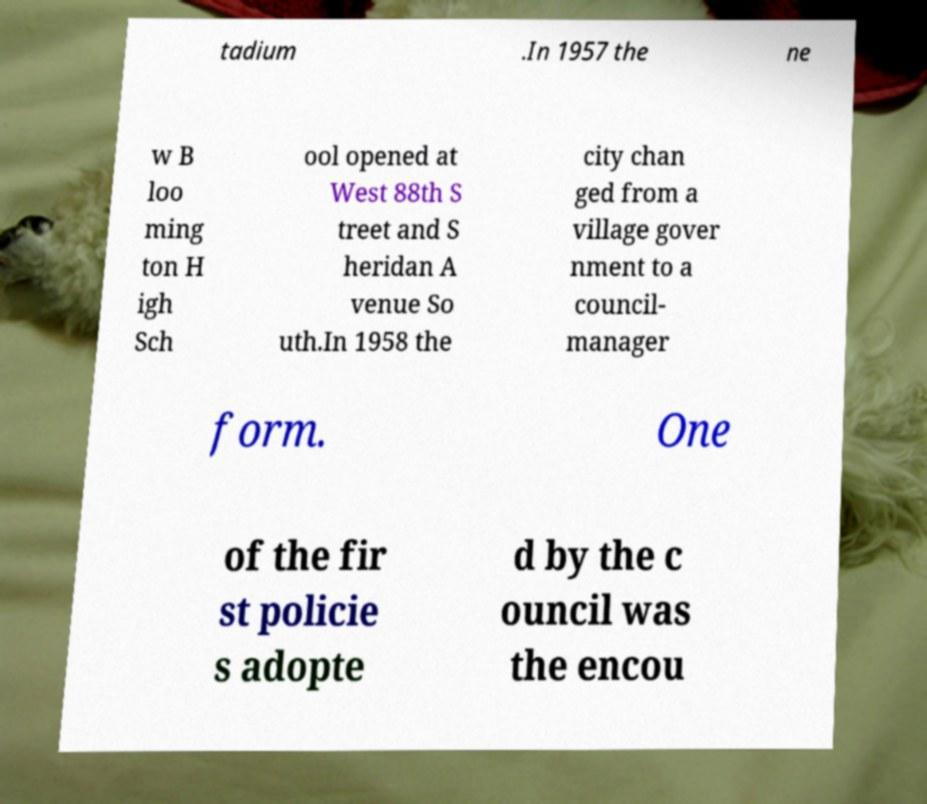Please identify and transcribe the text found in this image. tadium .In 1957 the ne w B loo ming ton H igh Sch ool opened at West 88th S treet and S heridan A venue So uth.In 1958 the city chan ged from a village gover nment to a council- manager form. One of the fir st policie s adopte d by the c ouncil was the encou 